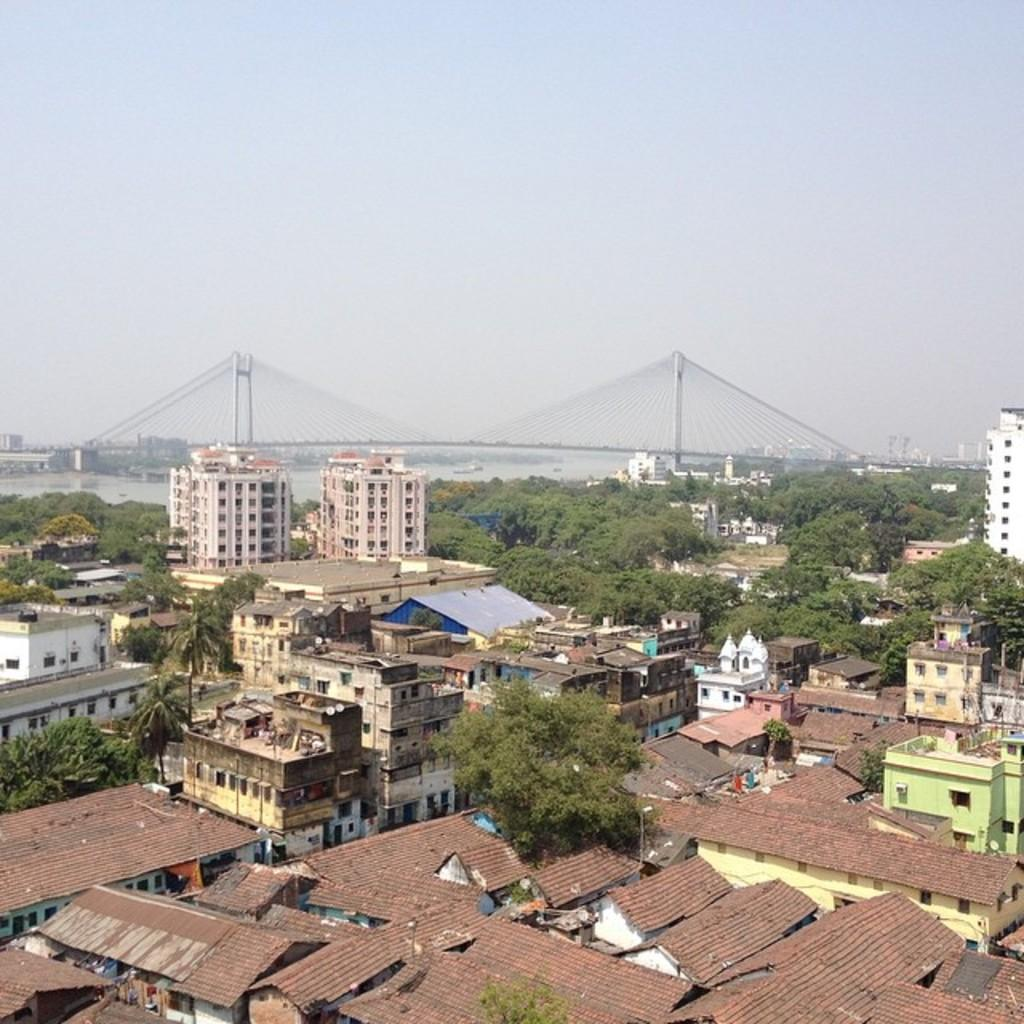What type of landscape is depicted in the image? The image shows a view of the city. What structures can be seen in the cityscape? There are buildings and houses in the image. What natural elements are present in the image? There are trees and a river in the image. What is visible in the sky in the image? There is sky visible in the image. Are there any architectural features that stand out in the image? Yes, there is a bridge in the image. Can you see any cobwebs in the image? There are no cobwebs present in the image. Is there a bear visible in the image? There is no bear present in the image. 